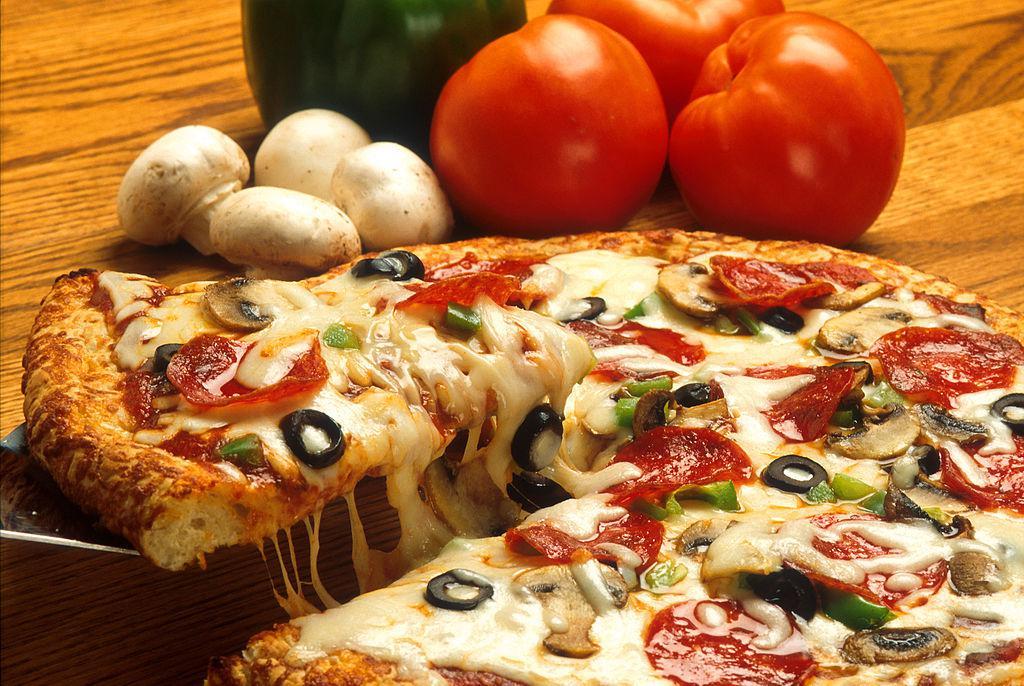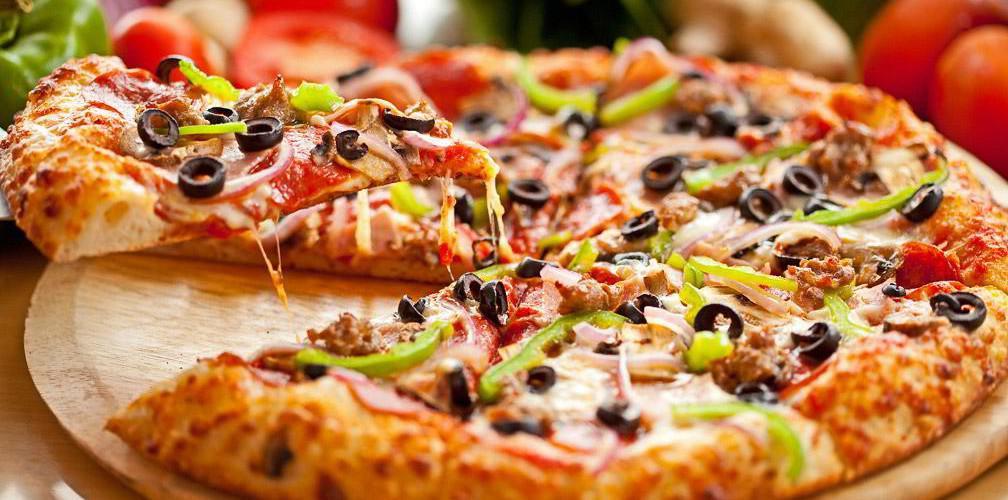The first image is the image on the left, the second image is the image on the right. Given the left and right images, does the statement "An image shows a single slice of pizza lifted upward, with cheese stretching all along the side." hold true? Answer yes or no. Yes. The first image is the image on the left, the second image is the image on the right. Examine the images to the left and right. Is the description "Someone is using a pizza server tool to help themselves to a slice of pizza in at least one of the pictures." accurate? Answer yes or no. Yes. 